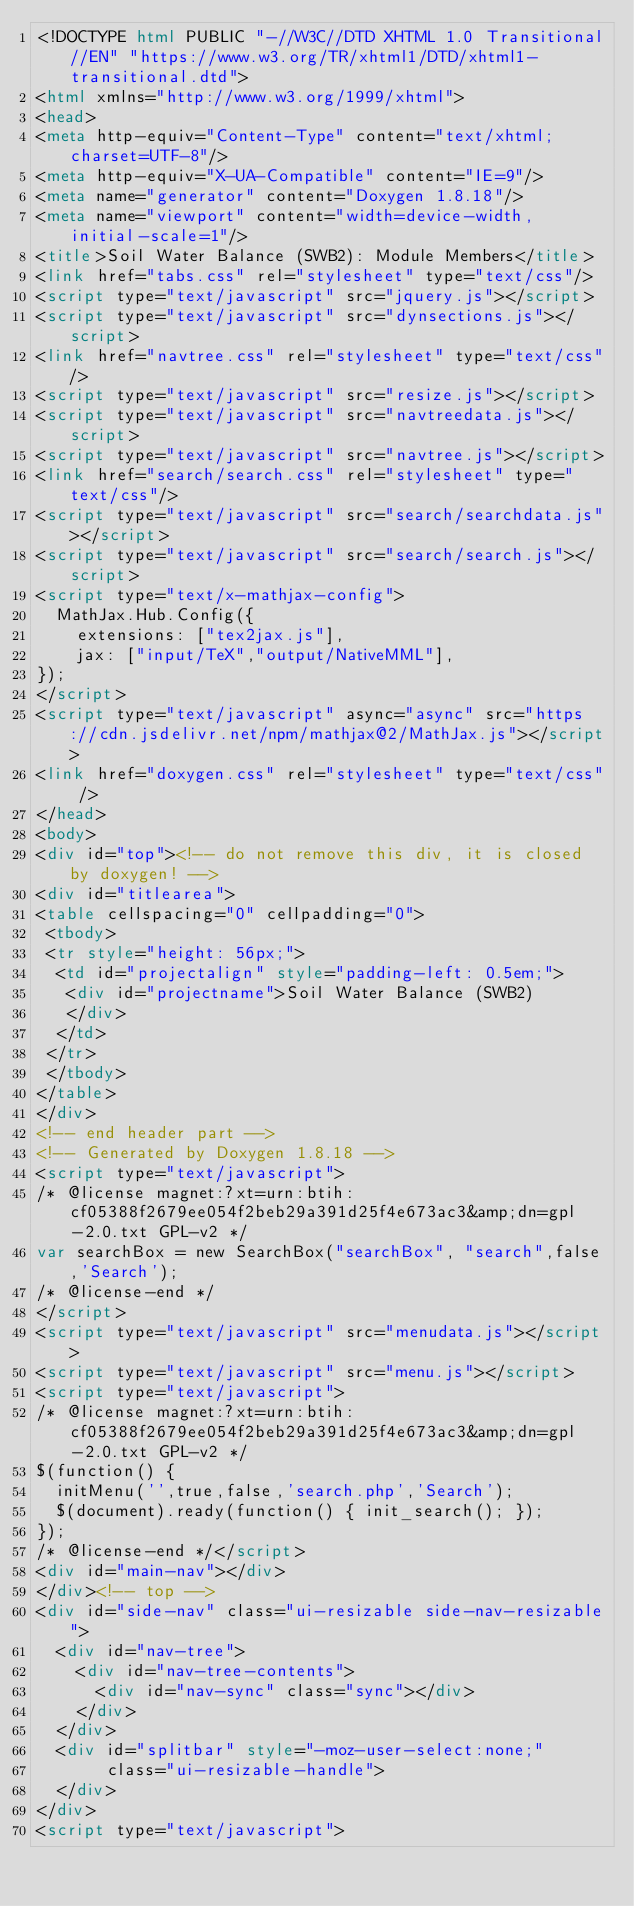<code> <loc_0><loc_0><loc_500><loc_500><_HTML_><!DOCTYPE html PUBLIC "-//W3C//DTD XHTML 1.0 Transitional//EN" "https://www.w3.org/TR/xhtml1/DTD/xhtml1-transitional.dtd">
<html xmlns="http://www.w3.org/1999/xhtml">
<head>
<meta http-equiv="Content-Type" content="text/xhtml;charset=UTF-8"/>
<meta http-equiv="X-UA-Compatible" content="IE=9"/>
<meta name="generator" content="Doxygen 1.8.18"/>
<meta name="viewport" content="width=device-width, initial-scale=1"/>
<title>Soil Water Balance (SWB2): Module Members</title>
<link href="tabs.css" rel="stylesheet" type="text/css"/>
<script type="text/javascript" src="jquery.js"></script>
<script type="text/javascript" src="dynsections.js"></script>
<link href="navtree.css" rel="stylesheet" type="text/css"/>
<script type="text/javascript" src="resize.js"></script>
<script type="text/javascript" src="navtreedata.js"></script>
<script type="text/javascript" src="navtree.js"></script>
<link href="search/search.css" rel="stylesheet" type="text/css"/>
<script type="text/javascript" src="search/searchdata.js"></script>
<script type="text/javascript" src="search/search.js"></script>
<script type="text/x-mathjax-config">
  MathJax.Hub.Config({
    extensions: ["tex2jax.js"],
    jax: ["input/TeX","output/NativeMML"],
});
</script>
<script type="text/javascript" async="async" src="https://cdn.jsdelivr.net/npm/mathjax@2/MathJax.js"></script>
<link href="doxygen.css" rel="stylesheet" type="text/css" />
</head>
<body>
<div id="top"><!-- do not remove this div, it is closed by doxygen! -->
<div id="titlearea">
<table cellspacing="0" cellpadding="0">
 <tbody>
 <tr style="height: 56px;">
  <td id="projectalign" style="padding-left: 0.5em;">
   <div id="projectname">Soil Water Balance (SWB2)
   </div>
  </td>
 </tr>
 </tbody>
</table>
</div>
<!-- end header part -->
<!-- Generated by Doxygen 1.8.18 -->
<script type="text/javascript">
/* @license magnet:?xt=urn:btih:cf05388f2679ee054f2beb29a391d25f4e673ac3&amp;dn=gpl-2.0.txt GPL-v2 */
var searchBox = new SearchBox("searchBox", "search",false,'Search');
/* @license-end */
</script>
<script type="text/javascript" src="menudata.js"></script>
<script type="text/javascript" src="menu.js"></script>
<script type="text/javascript">
/* @license magnet:?xt=urn:btih:cf05388f2679ee054f2beb29a391d25f4e673ac3&amp;dn=gpl-2.0.txt GPL-v2 */
$(function() {
  initMenu('',true,false,'search.php','Search');
  $(document).ready(function() { init_search(); });
});
/* @license-end */</script>
<div id="main-nav"></div>
</div><!-- top -->
<div id="side-nav" class="ui-resizable side-nav-resizable">
  <div id="nav-tree">
    <div id="nav-tree-contents">
      <div id="nav-sync" class="sync"></div>
    </div>
  </div>
  <div id="splitbar" style="-moz-user-select:none;" 
       class="ui-resizable-handle">
  </div>
</div>
<script type="text/javascript"></code> 